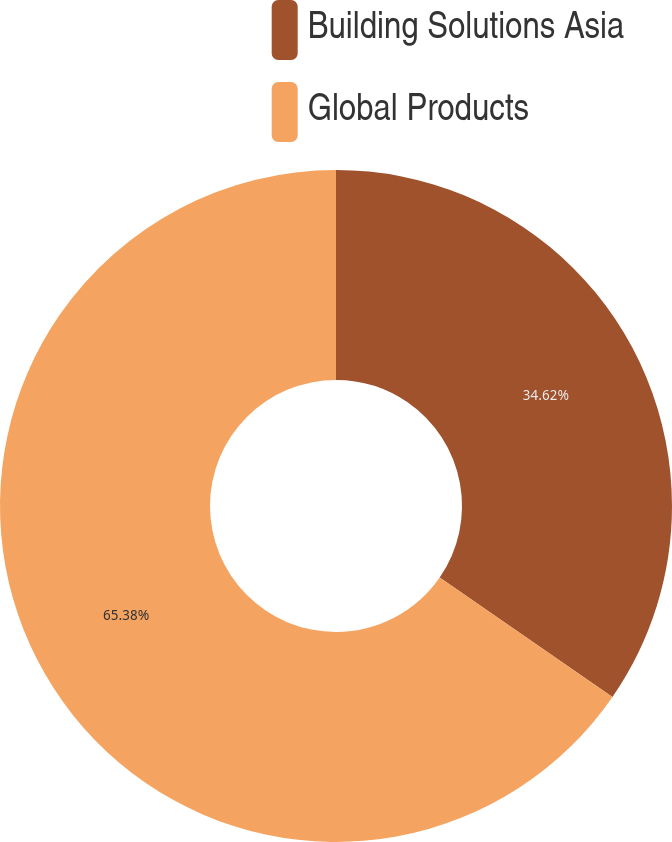<chart> <loc_0><loc_0><loc_500><loc_500><pie_chart><fcel>Building Solutions Asia<fcel>Global Products<nl><fcel>34.62%<fcel>65.38%<nl></chart> 